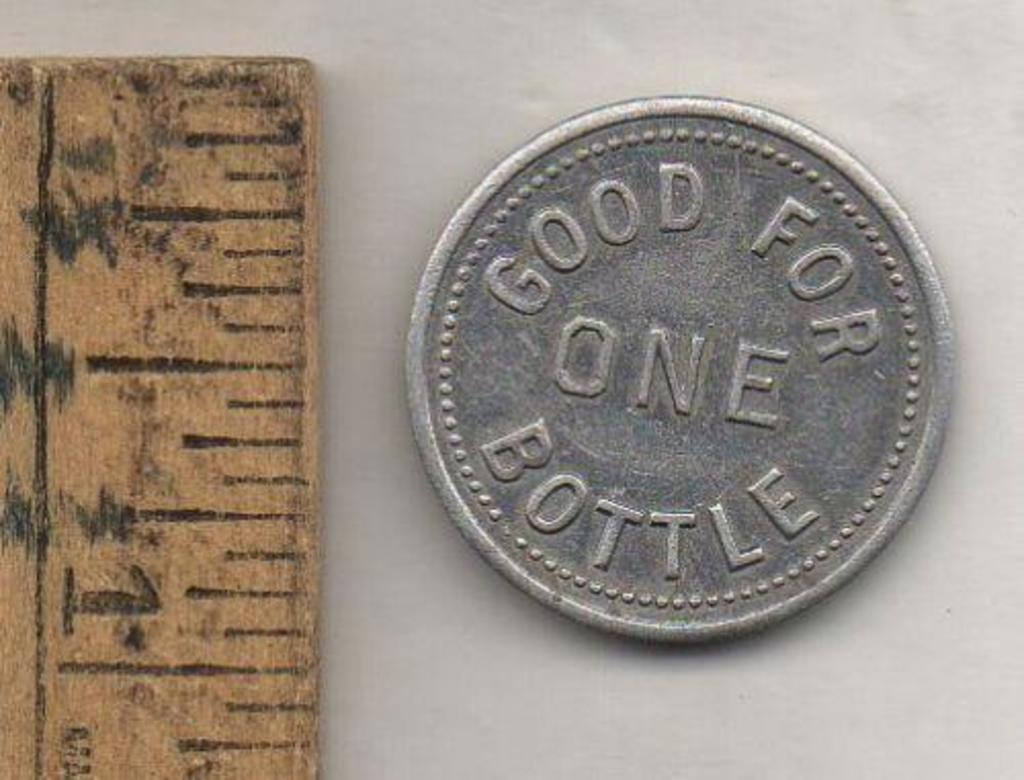<image>
Give a short and clear explanation of the subsequent image. A good for one bottle coin is placed next to a ruler. 